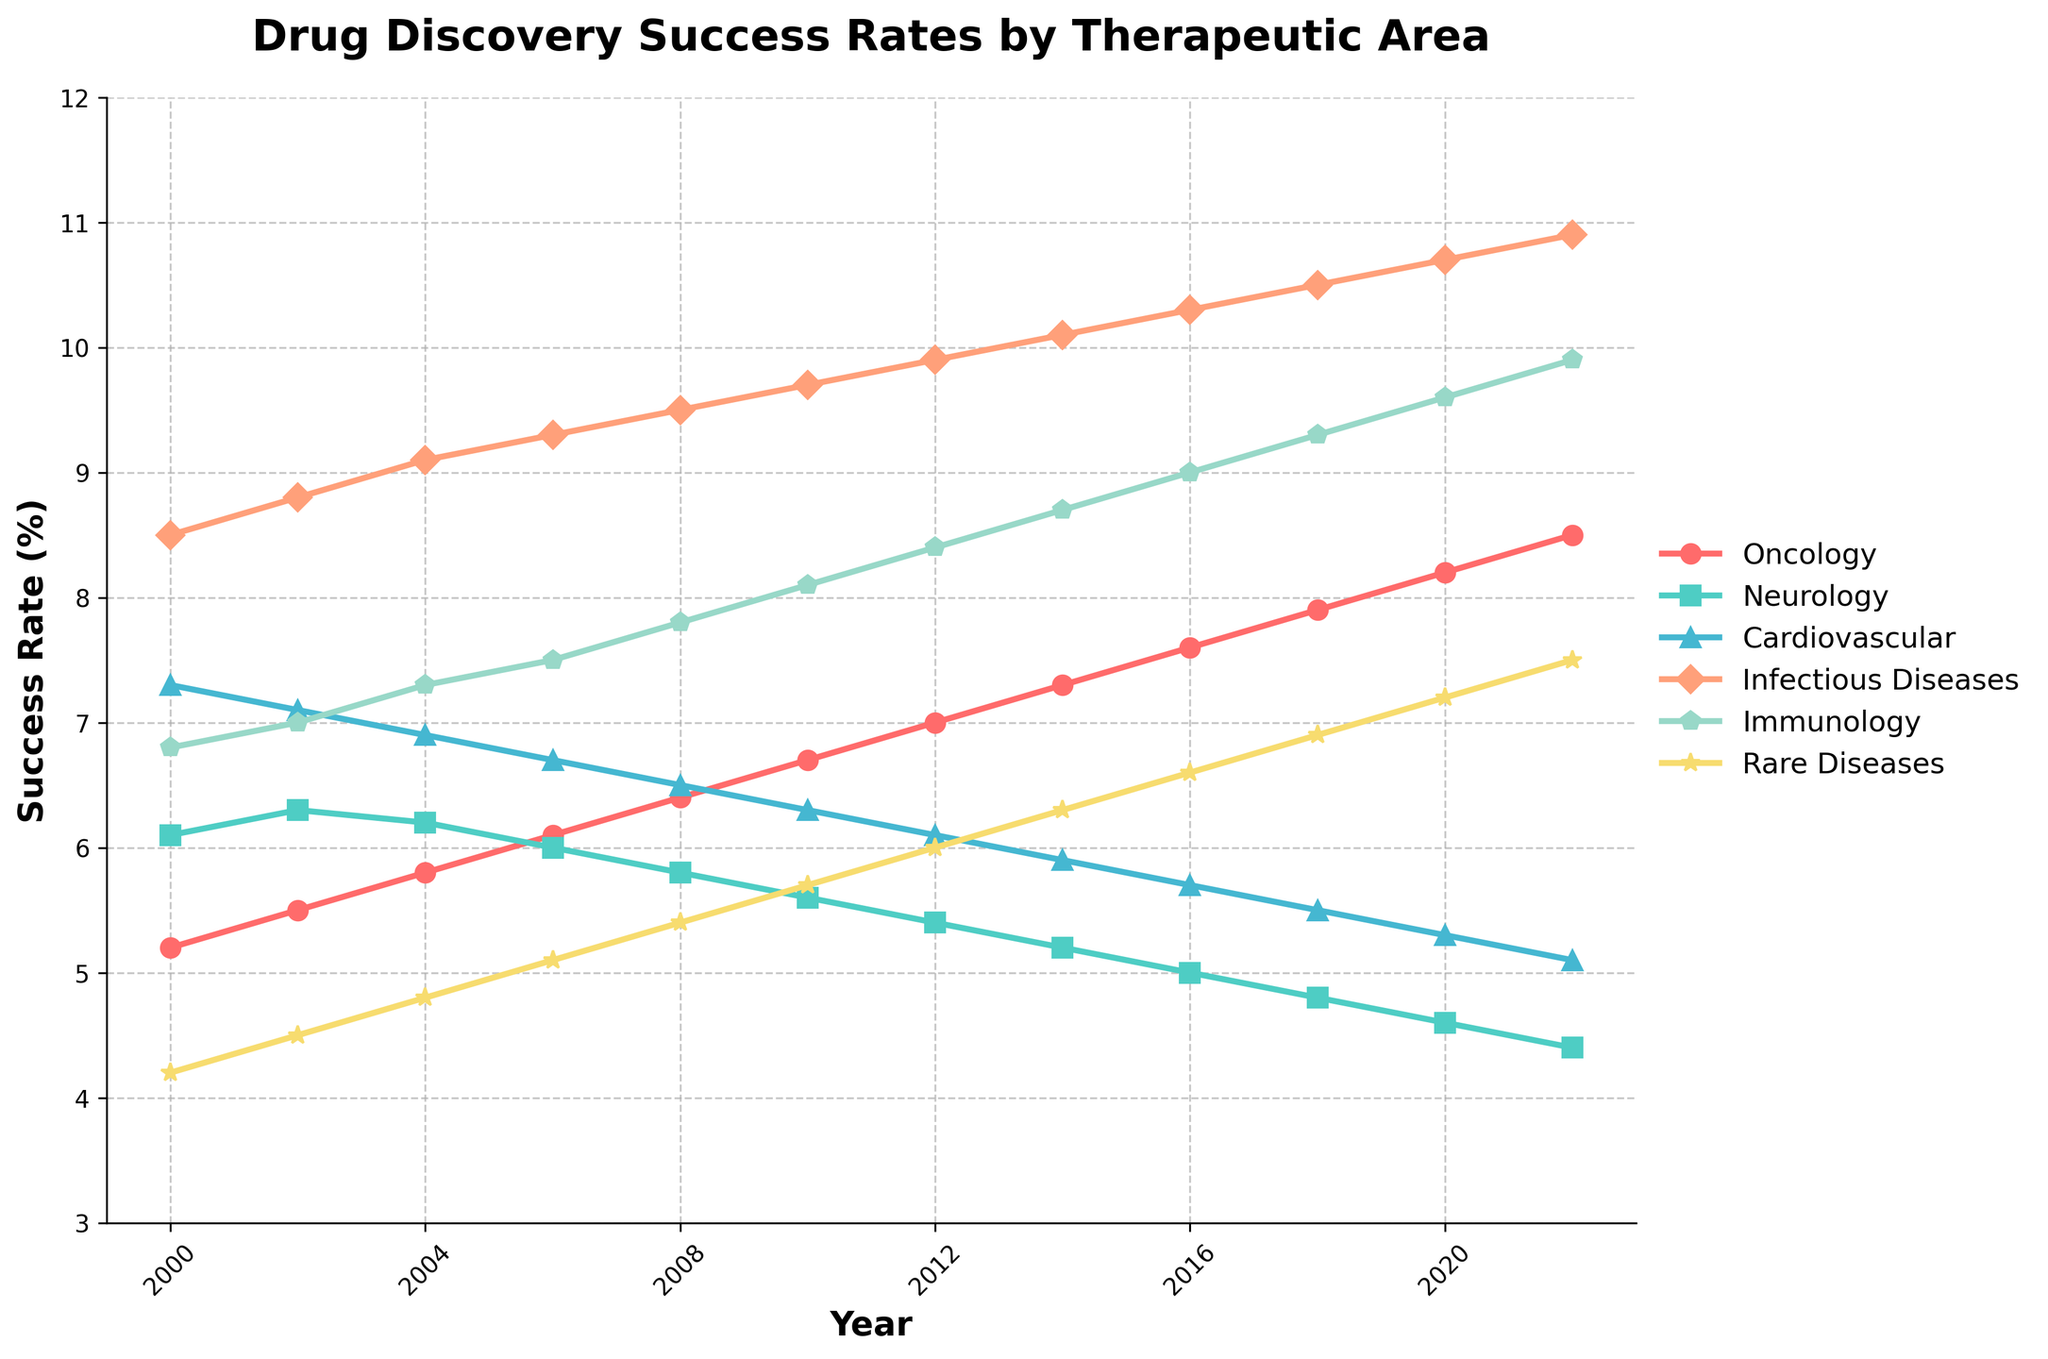What therapeutic area showed the greatest increase in success rate from 2000 to 2022? To determine this, first find the success rates for each therapeutic area in 2000 and 2022. Then calculate the differences for each area: Oncology (8.5 - 5.2 = 3.3), Neurology (4.4 - 6.1 = -1.7), Cardiovascular (5.1 - 7.3 = -2.2), Infectious Diseases (10.9 - 8.5 = 2.4), Immunology (9.9 - 6.8 = 3.1), Rare Diseases (7.5 - 4.2 = 3.3). The areas with the greatest increase are Oncology and Rare Diseases, both by 3.3.
Answer: Oncology and Rare Diseases Which therapeutic area had the highest success rate in 2022? Look at the success rates for each therapeutic area in the year 2022: Oncology (8.5), Neurology (4.4), Cardiovascular (5.1), Infectious Diseases (10.9), Immunology (9.9), Rare Diseases (7.5). The highest rate is in Infectious Diseases with 10.9.
Answer: Infectious Diseases What was the general trend in success rates for Immunology from 2000 to 2022? Observe the success rates of Immunology over the years: 2000 (6.8), 2002 (7.0), 2004 (7.3), 2006 (7.5), 2008 (7.8), 2010 (8.1), 2012 (8.4), 2014 (8.7), 2016 (9.0), 2018 (9.3), 2020 (9.6), 2022 (9.9). The success rate has shown a consistent upward trend in the given period.
Answer: Increasing trend Between 2010 and 2020, which therapeutic area saw the largest decrease in success rate? Calculate the difference in success rates for each area between 2010 and 2020: Oncology (8.2 - 6.7 = 1.5), Neurology (4.6 - 5.6 = -1.0), Cardiovascular (5.3 - 6.3 = -1.0), Infectious Diseases (10.7 - 9.7 = 1.0), Immunology (9.6 - 8.1 = 1.5), Rare Diseases (7.2 - 5.7 = 1.5). Both Neurology and Cardiovascular saw the same largest decrease of -1.0.
Answer: Neurology and Cardiovascular What is the average success rate for Oncology from 2000 to 2022? Add the success rates of Oncology for all the years and divide by the number of data points: (5.2 + 5.5 + 5.8 + 6.1 + 6.4 + 6.7 + 7.0 + 7.3 + 7.6 + 7.9 + 8.2 + 8.5) / 12 = 6.9167.
Answer: 6.92 What is the color representing Cardiovascular in the plot? Look at the plot and identify the line with the label "Cardiovascular". Note the color of this line. According to the provided code comments, the color is represented in a light blue tone.
Answer: light blue Which therapeutic area had the smallest range of success rates over the period 2000 to 2022? Calculate the range for each area by subtracting the smallest value from the largest value: Oncology (8.5 - 5.2 = 3.3), Neurology (6.1 - 4.4 = 1.7), Cardiovascular (7.3 - 5.1 = 2.2), Infectious Diseases (10.9 - 8.5 = 2.4), Immunology (9.9 - 6.8 = 3.1), Rare Diseases (7.5 - 4.2 = 3.3). The smallest range is for Neurology, which is 1.7.
Answer: Neurology 